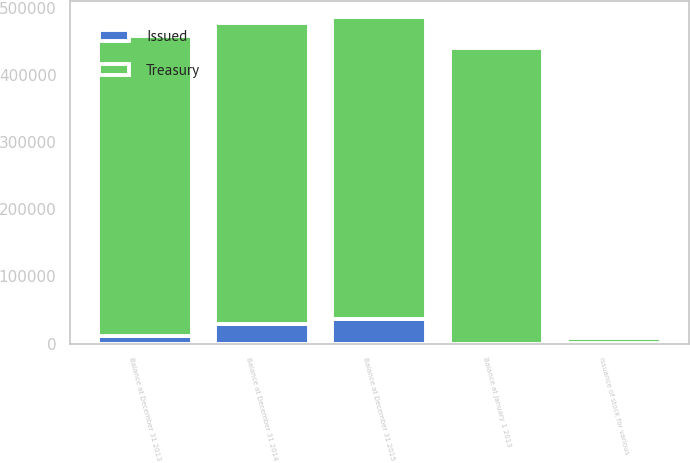Convert chart to OTSL. <chart><loc_0><loc_0><loc_500><loc_500><stacked_bar_chart><ecel><fcel>Balance at January 1 2013<fcel>Issuance of stock for various<fcel>Balance at December 31 2013<fcel>Balance at December 31 2014<fcel>Balance at December 31 2015<nl><fcel>Treasury<fcel>439894<fcel>7328<fcel>447222<fcel>448854<fcel>448916<nl><fcel>Issued<fcel>13<fcel>533<fcel>10868<fcel>28734<fcel>36776<nl></chart> 